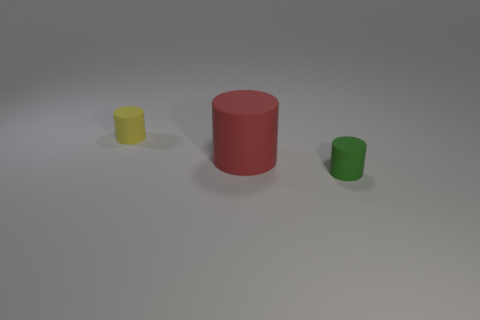How many small yellow things have the same material as the small green thing?
Your answer should be very brief. 1. What color is the tiny rubber object that is right of the tiny object behind the small green object?
Your answer should be compact. Green. The cylinder that is the same size as the green rubber thing is what color?
Keep it short and to the point. Yellow. Are there any tiny yellow shiny objects of the same shape as the red object?
Your response must be concise. No. There is a big object; what shape is it?
Make the answer very short. Cylinder. Is the number of objects that are on the right side of the large red matte object greater than the number of green matte objects that are in front of the green thing?
Make the answer very short. Yes. What number of other things are the same size as the red matte cylinder?
Provide a short and direct response. 0. The thing that is both behind the green cylinder and right of the yellow object is made of what material?
Your answer should be compact. Rubber. There is a small rubber cylinder that is left of the small cylinder that is on the right side of the tiny yellow cylinder; how many green cylinders are behind it?
Your answer should be compact. 0. How many rubber cylinders are in front of the red thing and on the left side of the large thing?
Provide a short and direct response. 0. 